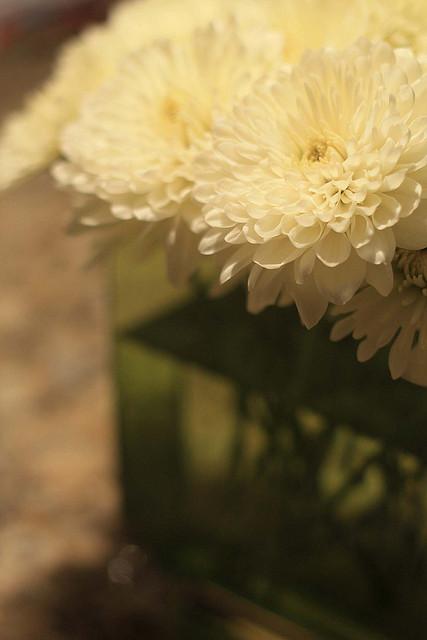Is this a cake topping?
Short answer required. No. What color are these flowers?
Be succinct. White. What is the main subject of this photo?
Concise answer only. Flowers. Is there water in the vase?
Write a very short answer. Yes. What is the flower wrapped around?
Answer briefly. Vase. Is there a plate?
Concise answer only. No. Is the vase green?
Answer briefly. Yes. 